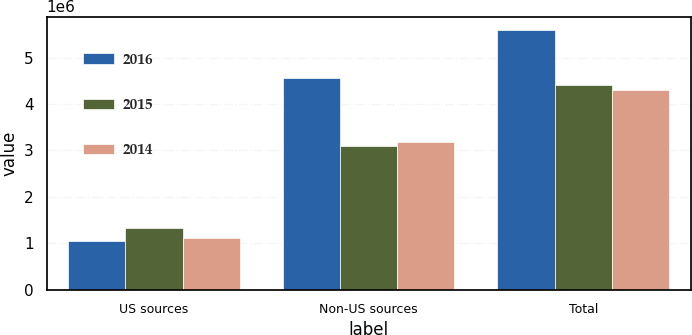Convert chart. <chart><loc_0><loc_0><loc_500><loc_500><stacked_bar_chart><ecel><fcel>US sources<fcel>Non-US sources<fcel>Total<nl><fcel>2016<fcel>1.04791e+06<fcel>4.55566e+06<fcel>5.60357e+06<nl><fcel>2015<fcel>1.32151e+06<fcel>3.08902e+06<fcel>4.41053e+06<nl><fcel>2014<fcel>1.11963e+06<fcel>3.17807e+06<fcel>4.2977e+06<nl></chart> 